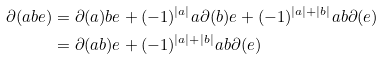<formula> <loc_0><loc_0><loc_500><loc_500>\partial ( a b e ) & = \partial ( a ) b e + ( - 1 ) ^ { | a | } a \partial ( b ) e + ( - 1 ) ^ { | a | + | b | } a b \partial ( e ) \\ & = \partial ( a b ) e + ( - 1 ) ^ { | a | + | b | } a b \partial ( e )</formula> 